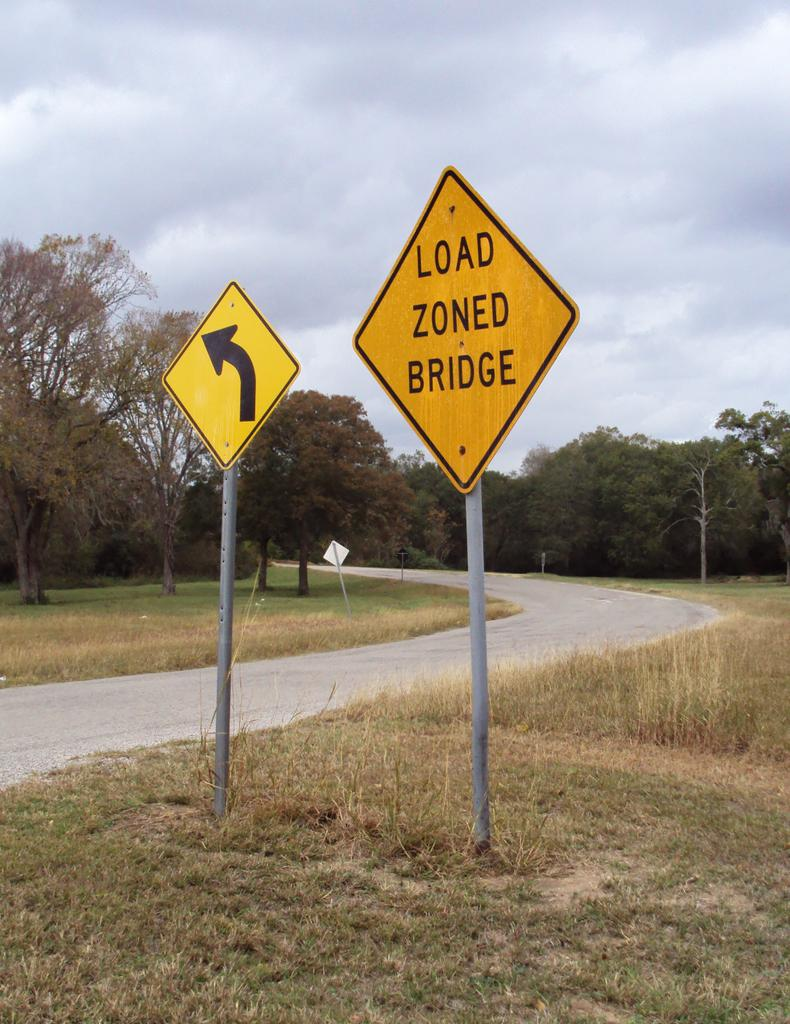<image>
Create a compact narrative representing the image presented. A yellow sign that reads 'LOAD ZONED BRIDGE' stands next to a road. 